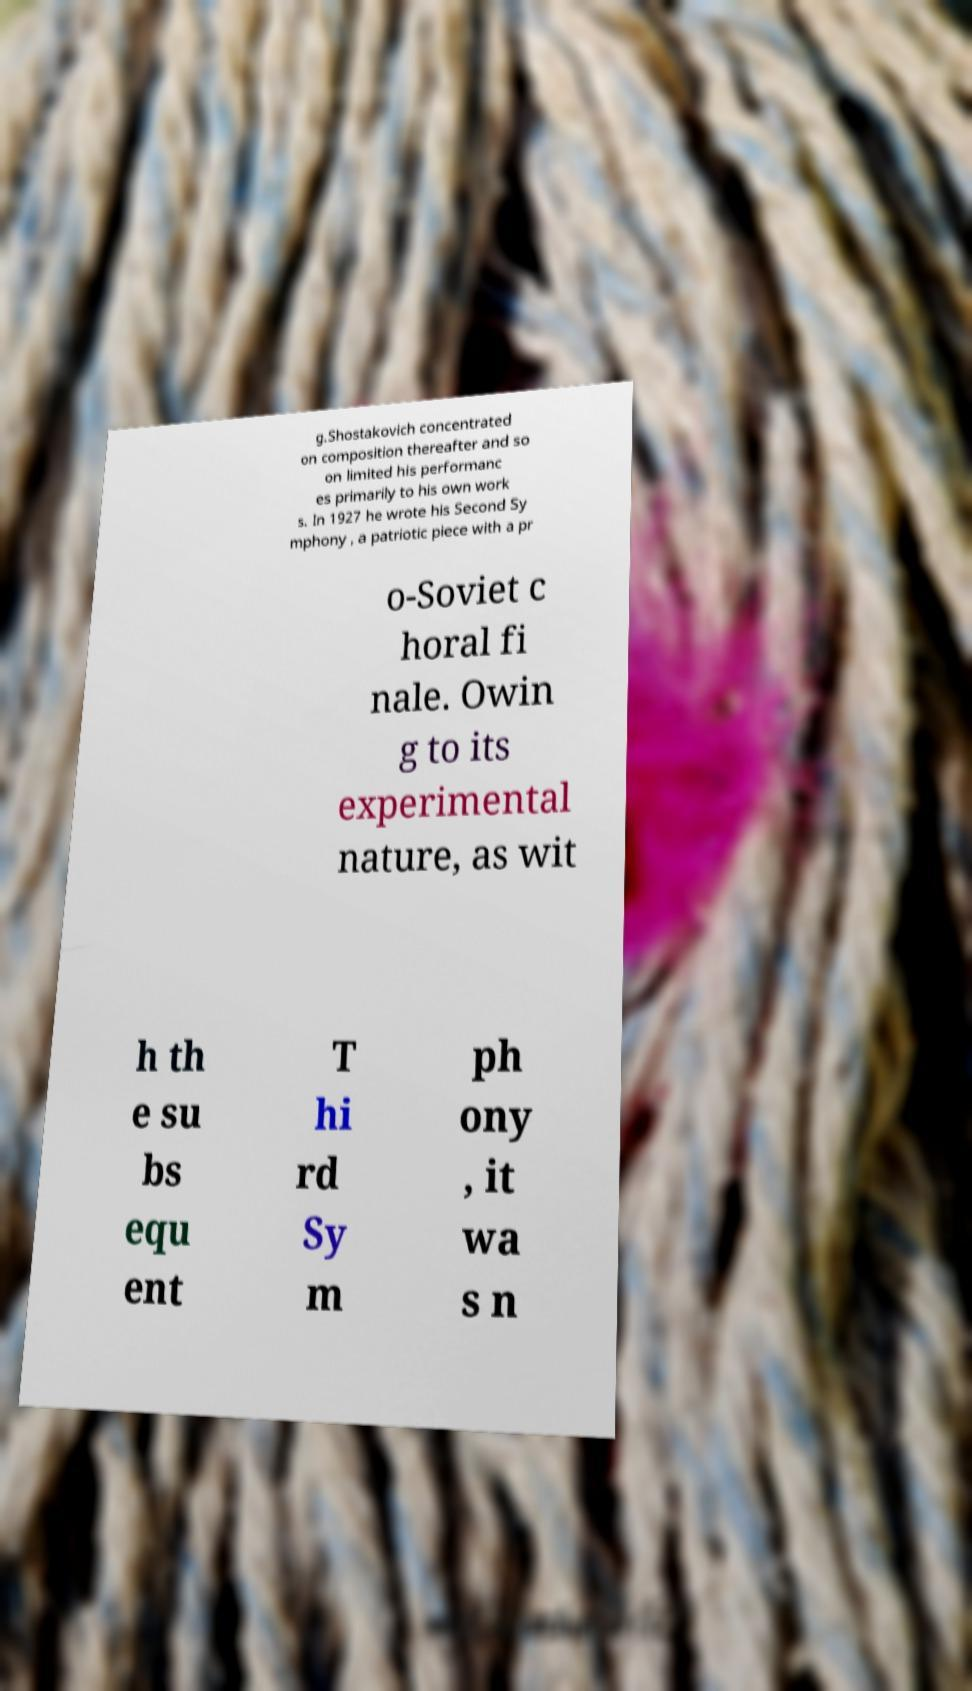Can you accurately transcribe the text from the provided image for me? g.Shostakovich concentrated on composition thereafter and so on limited his performanc es primarily to his own work s. In 1927 he wrote his Second Sy mphony , a patriotic piece with a pr o-Soviet c horal fi nale. Owin g to its experimental nature, as wit h th e su bs equ ent T hi rd Sy m ph ony , it wa s n 